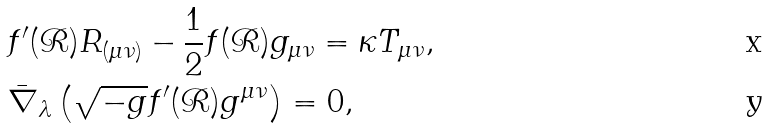Convert formula to latex. <formula><loc_0><loc_0><loc_500><loc_500>& f ^ { \prime } ( { \mathcal { R } } ) R _ { ( \mu \nu ) } - \frac { 1 } { 2 } f ( { \mathcal { R } } ) g _ { \mu \nu } = \kappa T _ { \mu \nu } , \\ & \bar { \nabla } _ { \lambda } \left ( \sqrt { - g } f ^ { \prime } ( { \mathcal { R } } ) g ^ { \mu \nu } \right ) = 0 ,</formula> 